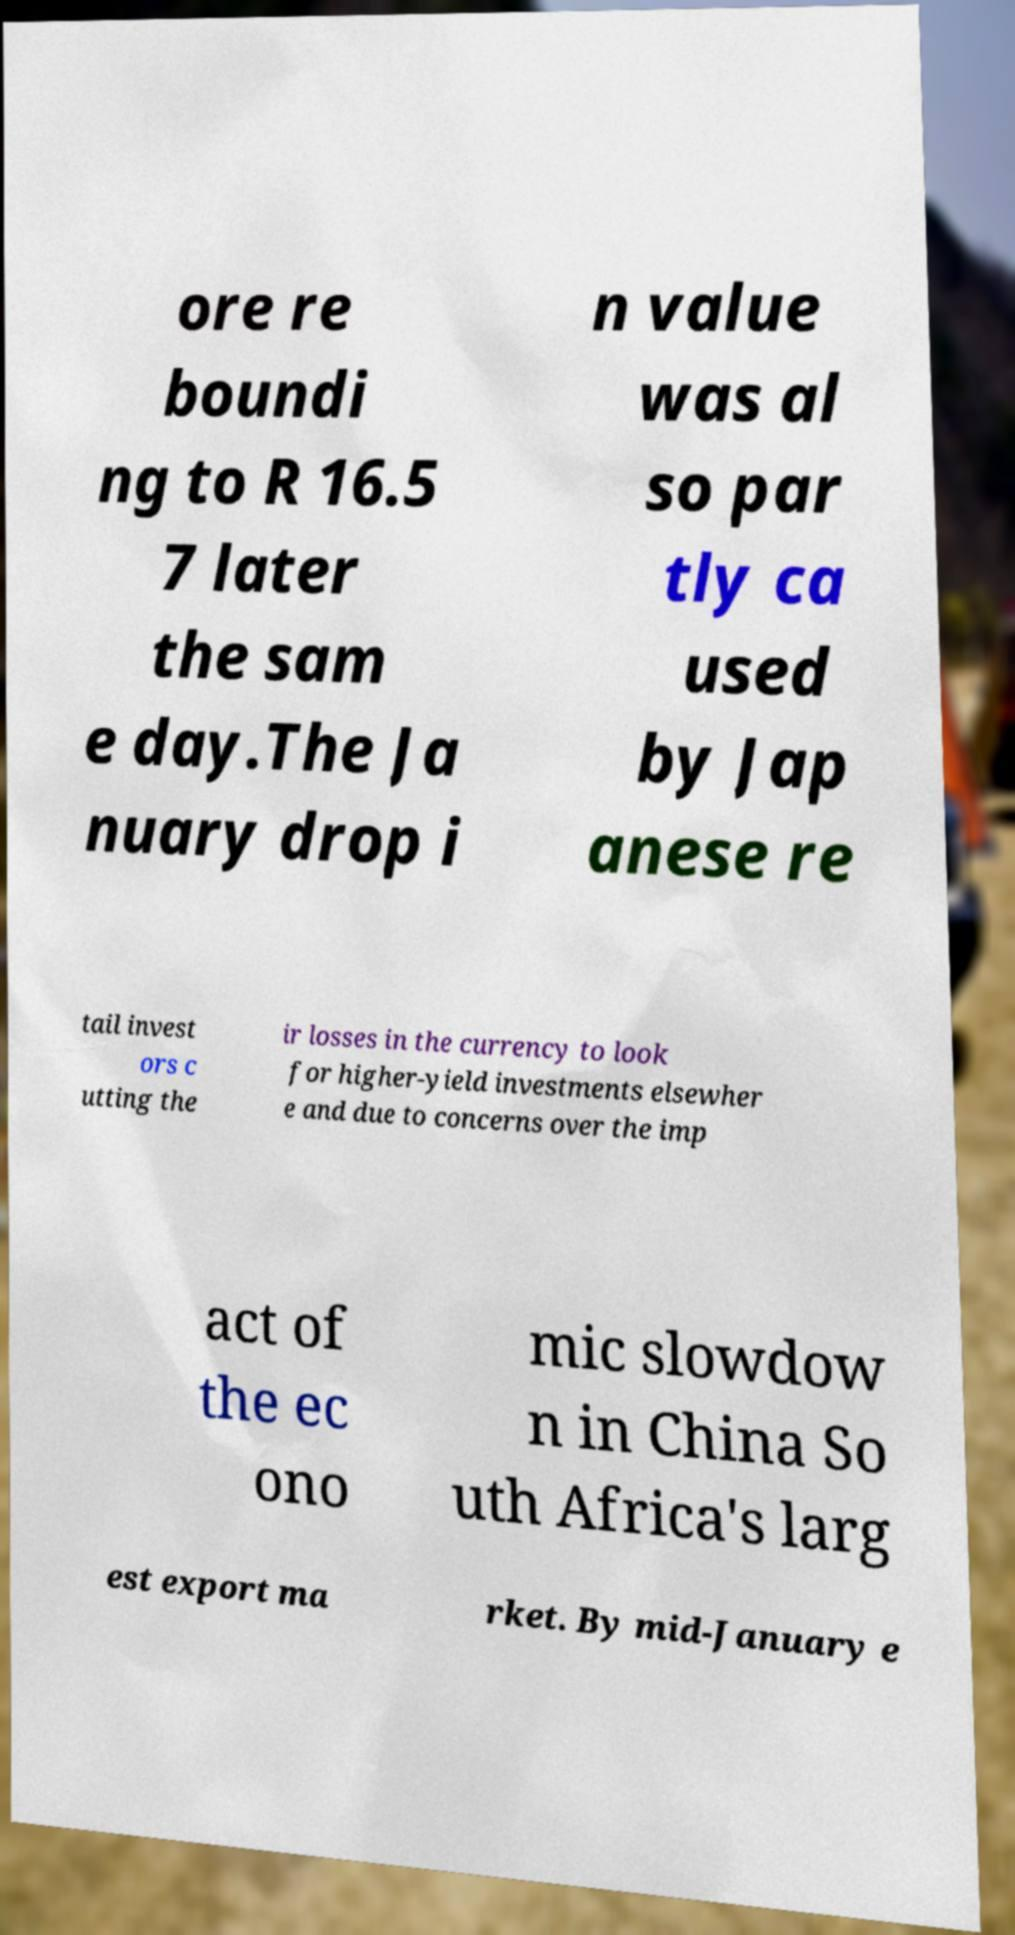There's text embedded in this image that I need extracted. Can you transcribe it verbatim? ore re boundi ng to R 16.5 7 later the sam e day.The Ja nuary drop i n value was al so par tly ca used by Jap anese re tail invest ors c utting the ir losses in the currency to look for higher-yield investments elsewher e and due to concerns over the imp act of the ec ono mic slowdow n in China So uth Africa's larg est export ma rket. By mid-January e 